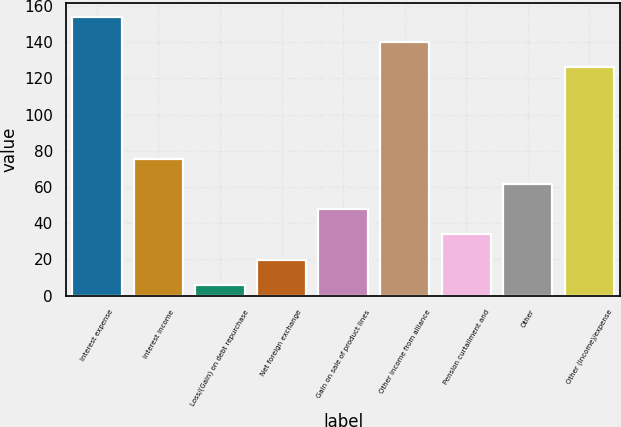Convert chart. <chart><loc_0><loc_0><loc_500><loc_500><bar_chart><fcel>Interest expense<fcel>Interest income<fcel>Loss/(Gain) on debt repurchase<fcel>Net foreign exchange<fcel>Gain on sale of product lines<fcel>Other income from alliance<fcel>Pension curtailment and<fcel>Other<fcel>Other (income)/expense<nl><fcel>153.8<fcel>75.5<fcel>6<fcel>19.9<fcel>47.7<fcel>139.9<fcel>33.8<fcel>61.6<fcel>126<nl></chart> 